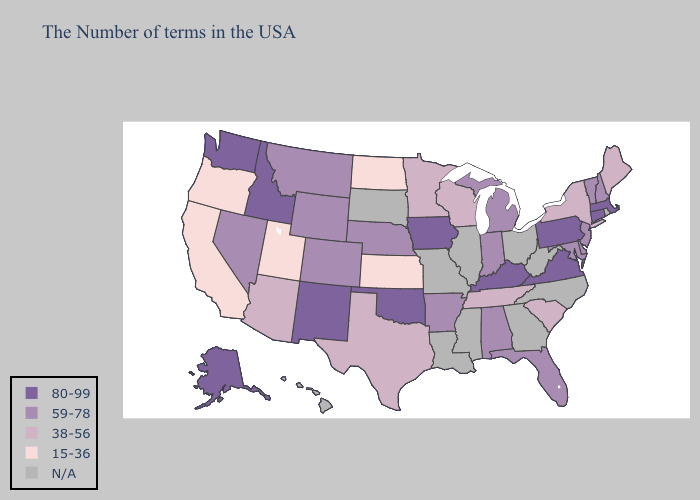Name the states that have a value in the range N/A?
Short answer required. Rhode Island, North Carolina, West Virginia, Ohio, Georgia, Illinois, Mississippi, Louisiana, Missouri, South Dakota, Hawaii. Name the states that have a value in the range 80-99?
Keep it brief. Massachusetts, Connecticut, Pennsylvania, Virginia, Kentucky, Iowa, Oklahoma, New Mexico, Idaho, Washington, Alaska. What is the lowest value in the Northeast?
Give a very brief answer. 38-56. Among the states that border Arkansas , does Oklahoma have the lowest value?
Concise answer only. No. Among the states that border Washington , does Oregon have the lowest value?
Keep it brief. Yes. What is the highest value in the USA?
Concise answer only. 80-99. Name the states that have a value in the range 38-56?
Quick response, please. Maine, New York, South Carolina, Tennessee, Wisconsin, Minnesota, Texas, Arizona. What is the value of Montana?
Quick response, please. 59-78. Name the states that have a value in the range 59-78?
Keep it brief. New Hampshire, Vermont, New Jersey, Delaware, Maryland, Florida, Michigan, Indiana, Alabama, Arkansas, Nebraska, Wyoming, Colorado, Montana, Nevada. Does Iowa have the highest value in the MidWest?
Answer briefly. Yes. What is the highest value in the Northeast ?
Give a very brief answer. 80-99. What is the highest value in states that border Arizona?
Answer briefly. 80-99. What is the value of Georgia?
Give a very brief answer. N/A. Name the states that have a value in the range 59-78?
Give a very brief answer. New Hampshire, Vermont, New Jersey, Delaware, Maryland, Florida, Michigan, Indiana, Alabama, Arkansas, Nebraska, Wyoming, Colorado, Montana, Nevada. 